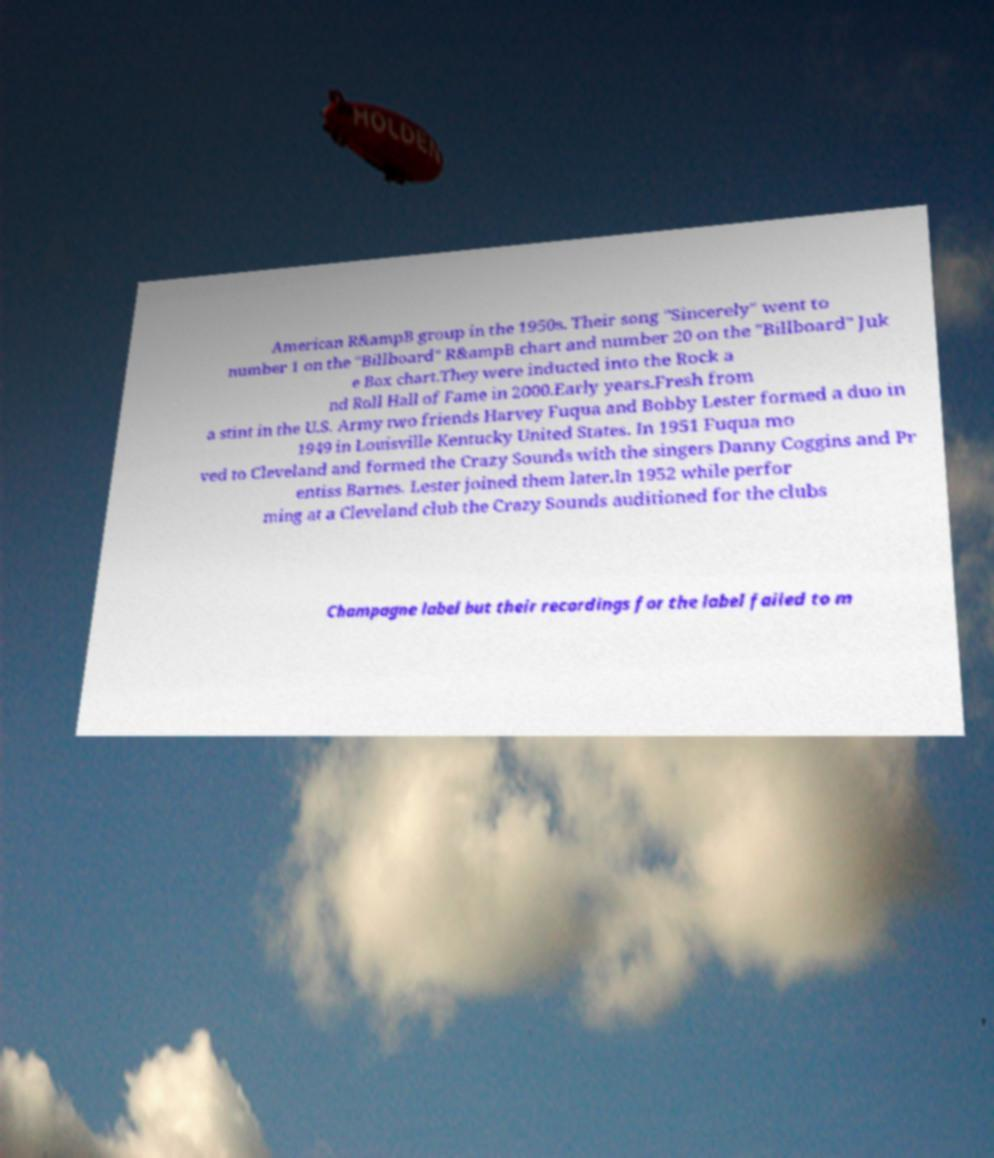I need the written content from this picture converted into text. Can you do that? American R&ampB group in the 1950s. Their song "Sincerely" went to number 1 on the "Billboard" R&ampB chart and number 20 on the "Billboard" Juk e Box chart.They were inducted into the Rock a nd Roll Hall of Fame in 2000.Early years.Fresh from a stint in the U.S. Army two friends Harvey Fuqua and Bobby Lester formed a duo in 1949 in Louisville Kentucky United States. In 1951 Fuqua mo ved to Cleveland and formed the Crazy Sounds with the singers Danny Coggins and Pr entiss Barnes. Lester joined them later.In 1952 while perfor ming at a Cleveland club the Crazy Sounds auditioned for the clubs Champagne label but their recordings for the label failed to m 